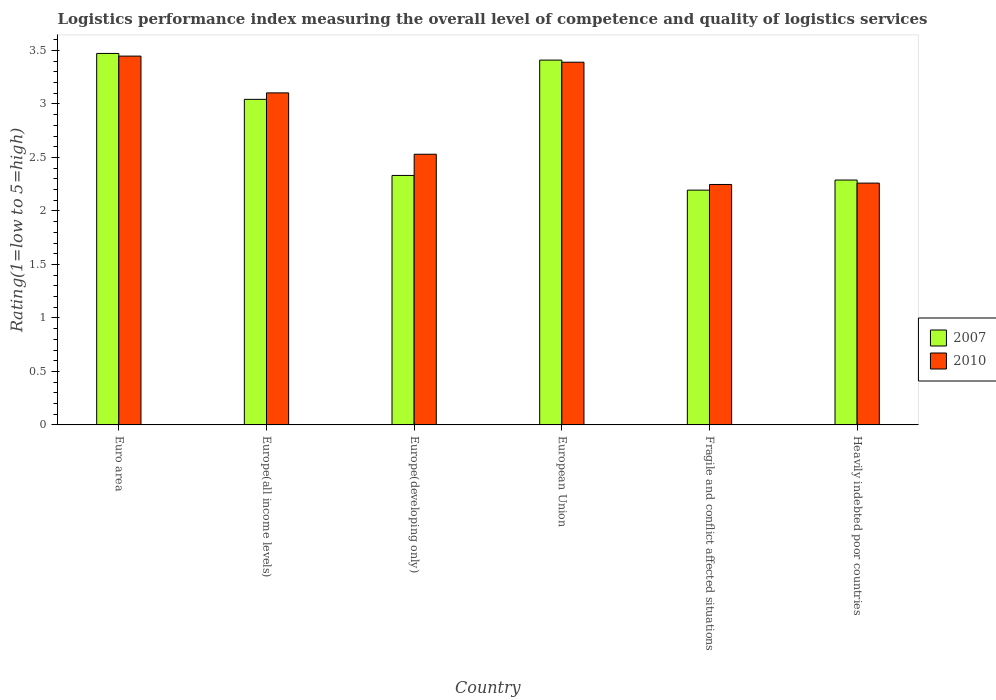How many different coloured bars are there?
Provide a short and direct response. 2. How many bars are there on the 4th tick from the left?
Provide a succinct answer. 2. What is the label of the 3rd group of bars from the left?
Give a very brief answer. Europe(developing only). What is the Logistic performance index in 2007 in Europe(developing only)?
Ensure brevity in your answer.  2.33. Across all countries, what is the maximum Logistic performance index in 2007?
Offer a terse response. 3.47. Across all countries, what is the minimum Logistic performance index in 2007?
Your answer should be compact. 2.19. In which country was the Logistic performance index in 2010 maximum?
Keep it short and to the point. Euro area. In which country was the Logistic performance index in 2007 minimum?
Offer a terse response. Fragile and conflict affected situations. What is the total Logistic performance index in 2007 in the graph?
Your answer should be very brief. 16.74. What is the difference between the Logistic performance index in 2010 in Europe(all income levels) and that in European Union?
Provide a succinct answer. -0.29. What is the difference between the Logistic performance index in 2007 in Heavily indebted poor countries and the Logistic performance index in 2010 in Europe(all income levels)?
Keep it short and to the point. -0.81. What is the average Logistic performance index in 2007 per country?
Provide a short and direct response. 2.79. What is the difference between the Logistic performance index of/in 2010 and Logistic performance index of/in 2007 in Euro area?
Offer a terse response. -0.02. What is the ratio of the Logistic performance index in 2010 in Europe(all income levels) to that in Fragile and conflict affected situations?
Offer a terse response. 1.38. Is the Logistic performance index in 2010 in Euro area less than that in Europe(all income levels)?
Keep it short and to the point. No. What is the difference between the highest and the second highest Logistic performance index in 2010?
Your answer should be compact. -0.06. What is the difference between the highest and the lowest Logistic performance index in 2010?
Offer a terse response. 1.2. In how many countries, is the Logistic performance index in 2007 greater than the average Logistic performance index in 2007 taken over all countries?
Ensure brevity in your answer.  3. What does the 1st bar from the right in European Union represents?
Offer a terse response. 2010. What is the difference between two consecutive major ticks on the Y-axis?
Your answer should be compact. 0.5. Are the values on the major ticks of Y-axis written in scientific E-notation?
Your response must be concise. No. Does the graph contain any zero values?
Provide a succinct answer. No. Where does the legend appear in the graph?
Offer a very short reply. Center right. How many legend labels are there?
Keep it short and to the point. 2. How are the legend labels stacked?
Provide a short and direct response. Vertical. What is the title of the graph?
Provide a succinct answer. Logistics performance index measuring the overall level of competence and quality of logistics services. What is the label or title of the Y-axis?
Your answer should be very brief. Rating(1=low to 5=high). What is the Rating(1=low to 5=high) of 2007 in Euro area?
Your answer should be very brief. 3.47. What is the Rating(1=low to 5=high) of 2010 in Euro area?
Your response must be concise. 3.45. What is the Rating(1=low to 5=high) of 2007 in Europe(all income levels)?
Your answer should be compact. 3.04. What is the Rating(1=low to 5=high) of 2010 in Europe(all income levels)?
Offer a terse response. 3.1. What is the Rating(1=low to 5=high) of 2007 in Europe(developing only)?
Offer a terse response. 2.33. What is the Rating(1=low to 5=high) in 2010 in Europe(developing only)?
Your answer should be very brief. 2.53. What is the Rating(1=low to 5=high) of 2007 in European Union?
Keep it short and to the point. 3.41. What is the Rating(1=low to 5=high) of 2010 in European Union?
Ensure brevity in your answer.  3.39. What is the Rating(1=low to 5=high) of 2007 in Fragile and conflict affected situations?
Ensure brevity in your answer.  2.19. What is the Rating(1=low to 5=high) in 2010 in Fragile and conflict affected situations?
Make the answer very short. 2.25. What is the Rating(1=low to 5=high) of 2007 in Heavily indebted poor countries?
Ensure brevity in your answer.  2.29. What is the Rating(1=low to 5=high) in 2010 in Heavily indebted poor countries?
Offer a very short reply. 2.26. Across all countries, what is the maximum Rating(1=low to 5=high) in 2007?
Your answer should be very brief. 3.47. Across all countries, what is the maximum Rating(1=low to 5=high) in 2010?
Make the answer very short. 3.45. Across all countries, what is the minimum Rating(1=low to 5=high) in 2007?
Your answer should be very brief. 2.19. Across all countries, what is the minimum Rating(1=low to 5=high) of 2010?
Your answer should be compact. 2.25. What is the total Rating(1=low to 5=high) in 2007 in the graph?
Provide a succinct answer. 16.74. What is the total Rating(1=low to 5=high) in 2010 in the graph?
Offer a very short reply. 16.98. What is the difference between the Rating(1=low to 5=high) in 2007 in Euro area and that in Europe(all income levels)?
Offer a terse response. 0.43. What is the difference between the Rating(1=low to 5=high) of 2010 in Euro area and that in Europe(all income levels)?
Offer a very short reply. 0.34. What is the difference between the Rating(1=low to 5=high) in 2007 in Euro area and that in Europe(developing only)?
Offer a terse response. 1.14. What is the difference between the Rating(1=low to 5=high) of 2010 in Euro area and that in Europe(developing only)?
Provide a succinct answer. 0.92. What is the difference between the Rating(1=low to 5=high) of 2007 in Euro area and that in European Union?
Provide a succinct answer. 0.06. What is the difference between the Rating(1=low to 5=high) in 2010 in Euro area and that in European Union?
Keep it short and to the point. 0.06. What is the difference between the Rating(1=low to 5=high) of 2007 in Euro area and that in Fragile and conflict affected situations?
Offer a very short reply. 1.28. What is the difference between the Rating(1=low to 5=high) of 2010 in Euro area and that in Fragile and conflict affected situations?
Provide a succinct answer. 1.2. What is the difference between the Rating(1=low to 5=high) in 2007 in Euro area and that in Heavily indebted poor countries?
Ensure brevity in your answer.  1.18. What is the difference between the Rating(1=low to 5=high) of 2010 in Euro area and that in Heavily indebted poor countries?
Give a very brief answer. 1.19. What is the difference between the Rating(1=low to 5=high) of 2007 in Europe(all income levels) and that in Europe(developing only)?
Your response must be concise. 0.71. What is the difference between the Rating(1=low to 5=high) of 2010 in Europe(all income levels) and that in Europe(developing only)?
Offer a terse response. 0.57. What is the difference between the Rating(1=low to 5=high) of 2007 in Europe(all income levels) and that in European Union?
Keep it short and to the point. -0.37. What is the difference between the Rating(1=low to 5=high) in 2010 in Europe(all income levels) and that in European Union?
Offer a very short reply. -0.29. What is the difference between the Rating(1=low to 5=high) in 2007 in Europe(all income levels) and that in Fragile and conflict affected situations?
Offer a terse response. 0.85. What is the difference between the Rating(1=low to 5=high) in 2010 in Europe(all income levels) and that in Fragile and conflict affected situations?
Your answer should be very brief. 0.86. What is the difference between the Rating(1=low to 5=high) in 2007 in Europe(all income levels) and that in Heavily indebted poor countries?
Keep it short and to the point. 0.75. What is the difference between the Rating(1=low to 5=high) of 2010 in Europe(all income levels) and that in Heavily indebted poor countries?
Provide a short and direct response. 0.84. What is the difference between the Rating(1=low to 5=high) of 2007 in Europe(developing only) and that in European Union?
Your answer should be very brief. -1.08. What is the difference between the Rating(1=low to 5=high) in 2010 in Europe(developing only) and that in European Union?
Give a very brief answer. -0.86. What is the difference between the Rating(1=low to 5=high) of 2007 in Europe(developing only) and that in Fragile and conflict affected situations?
Provide a succinct answer. 0.14. What is the difference between the Rating(1=low to 5=high) in 2010 in Europe(developing only) and that in Fragile and conflict affected situations?
Keep it short and to the point. 0.28. What is the difference between the Rating(1=low to 5=high) of 2007 in Europe(developing only) and that in Heavily indebted poor countries?
Make the answer very short. 0.04. What is the difference between the Rating(1=low to 5=high) in 2010 in Europe(developing only) and that in Heavily indebted poor countries?
Provide a short and direct response. 0.27. What is the difference between the Rating(1=low to 5=high) in 2007 in European Union and that in Fragile and conflict affected situations?
Offer a terse response. 1.22. What is the difference between the Rating(1=low to 5=high) in 2007 in European Union and that in Heavily indebted poor countries?
Offer a very short reply. 1.12. What is the difference between the Rating(1=low to 5=high) of 2010 in European Union and that in Heavily indebted poor countries?
Keep it short and to the point. 1.13. What is the difference between the Rating(1=low to 5=high) in 2007 in Fragile and conflict affected situations and that in Heavily indebted poor countries?
Keep it short and to the point. -0.09. What is the difference between the Rating(1=low to 5=high) in 2010 in Fragile and conflict affected situations and that in Heavily indebted poor countries?
Make the answer very short. -0.01. What is the difference between the Rating(1=low to 5=high) of 2007 in Euro area and the Rating(1=low to 5=high) of 2010 in Europe(all income levels)?
Provide a short and direct response. 0.37. What is the difference between the Rating(1=low to 5=high) in 2007 in Euro area and the Rating(1=low to 5=high) in 2010 in Europe(developing only)?
Give a very brief answer. 0.94. What is the difference between the Rating(1=low to 5=high) of 2007 in Euro area and the Rating(1=low to 5=high) of 2010 in European Union?
Offer a very short reply. 0.08. What is the difference between the Rating(1=low to 5=high) of 2007 in Euro area and the Rating(1=low to 5=high) of 2010 in Fragile and conflict affected situations?
Your response must be concise. 1.22. What is the difference between the Rating(1=low to 5=high) in 2007 in Euro area and the Rating(1=low to 5=high) in 2010 in Heavily indebted poor countries?
Your answer should be very brief. 1.21. What is the difference between the Rating(1=low to 5=high) of 2007 in Europe(all income levels) and the Rating(1=low to 5=high) of 2010 in Europe(developing only)?
Provide a succinct answer. 0.51. What is the difference between the Rating(1=low to 5=high) in 2007 in Europe(all income levels) and the Rating(1=low to 5=high) in 2010 in European Union?
Ensure brevity in your answer.  -0.35. What is the difference between the Rating(1=low to 5=high) in 2007 in Europe(all income levels) and the Rating(1=low to 5=high) in 2010 in Fragile and conflict affected situations?
Your answer should be very brief. 0.8. What is the difference between the Rating(1=low to 5=high) of 2007 in Europe(all income levels) and the Rating(1=low to 5=high) of 2010 in Heavily indebted poor countries?
Your answer should be compact. 0.78. What is the difference between the Rating(1=low to 5=high) in 2007 in Europe(developing only) and the Rating(1=low to 5=high) in 2010 in European Union?
Your response must be concise. -1.06. What is the difference between the Rating(1=low to 5=high) of 2007 in Europe(developing only) and the Rating(1=low to 5=high) of 2010 in Fragile and conflict affected situations?
Your answer should be very brief. 0.08. What is the difference between the Rating(1=low to 5=high) in 2007 in Europe(developing only) and the Rating(1=low to 5=high) in 2010 in Heavily indebted poor countries?
Provide a short and direct response. 0.07. What is the difference between the Rating(1=low to 5=high) of 2007 in European Union and the Rating(1=low to 5=high) of 2010 in Fragile and conflict affected situations?
Ensure brevity in your answer.  1.16. What is the difference between the Rating(1=low to 5=high) of 2007 in European Union and the Rating(1=low to 5=high) of 2010 in Heavily indebted poor countries?
Your answer should be very brief. 1.15. What is the difference between the Rating(1=low to 5=high) of 2007 in Fragile and conflict affected situations and the Rating(1=low to 5=high) of 2010 in Heavily indebted poor countries?
Provide a short and direct response. -0.07. What is the average Rating(1=low to 5=high) of 2007 per country?
Your answer should be compact. 2.79. What is the average Rating(1=low to 5=high) in 2010 per country?
Offer a terse response. 2.83. What is the difference between the Rating(1=low to 5=high) in 2007 and Rating(1=low to 5=high) in 2010 in Euro area?
Your answer should be compact. 0.02. What is the difference between the Rating(1=low to 5=high) of 2007 and Rating(1=low to 5=high) of 2010 in Europe(all income levels)?
Make the answer very short. -0.06. What is the difference between the Rating(1=low to 5=high) in 2007 and Rating(1=low to 5=high) in 2010 in Europe(developing only)?
Keep it short and to the point. -0.2. What is the difference between the Rating(1=low to 5=high) of 2007 and Rating(1=low to 5=high) of 2010 in European Union?
Provide a short and direct response. 0.02. What is the difference between the Rating(1=low to 5=high) in 2007 and Rating(1=low to 5=high) in 2010 in Fragile and conflict affected situations?
Make the answer very short. -0.05. What is the difference between the Rating(1=low to 5=high) in 2007 and Rating(1=low to 5=high) in 2010 in Heavily indebted poor countries?
Give a very brief answer. 0.03. What is the ratio of the Rating(1=low to 5=high) of 2007 in Euro area to that in Europe(all income levels)?
Your answer should be very brief. 1.14. What is the ratio of the Rating(1=low to 5=high) of 2010 in Euro area to that in Europe(all income levels)?
Offer a very short reply. 1.11. What is the ratio of the Rating(1=low to 5=high) in 2007 in Euro area to that in Europe(developing only)?
Make the answer very short. 1.49. What is the ratio of the Rating(1=low to 5=high) of 2010 in Euro area to that in Europe(developing only)?
Your answer should be compact. 1.36. What is the ratio of the Rating(1=low to 5=high) in 2007 in Euro area to that in European Union?
Ensure brevity in your answer.  1.02. What is the ratio of the Rating(1=low to 5=high) of 2010 in Euro area to that in European Union?
Provide a short and direct response. 1.02. What is the ratio of the Rating(1=low to 5=high) of 2007 in Euro area to that in Fragile and conflict affected situations?
Offer a very short reply. 1.58. What is the ratio of the Rating(1=low to 5=high) of 2010 in Euro area to that in Fragile and conflict affected situations?
Offer a very short reply. 1.53. What is the ratio of the Rating(1=low to 5=high) of 2007 in Euro area to that in Heavily indebted poor countries?
Your response must be concise. 1.52. What is the ratio of the Rating(1=low to 5=high) of 2010 in Euro area to that in Heavily indebted poor countries?
Offer a very short reply. 1.53. What is the ratio of the Rating(1=low to 5=high) in 2007 in Europe(all income levels) to that in Europe(developing only)?
Provide a succinct answer. 1.3. What is the ratio of the Rating(1=low to 5=high) of 2010 in Europe(all income levels) to that in Europe(developing only)?
Your response must be concise. 1.23. What is the ratio of the Rating(1=low to 5=high) in 2007 in Europe(all income levels) to that in European Union?
Your answer should be very brief. 0.89. What is the ratio of the Rating(1=low to 5=high) in 2010 in Europe(all income levels) to that in European Union?
Provide a short and direct response. 0.92. What is the ratio of the Rating(1=low to 5=high) of 2007 in Europe(all income levels) to that in Fragile and conflict affected situations?
Make the answer very short. 1.39. What is the ratio of the Rating(1=low to 5=high) of 2010 in Europe(all income levels) to that in Fragile and conflict affected situations?
Give a very brief answer. 1.38. What is the ratio of the Rating(1=low to 5=high) in 2007 in Europe(all income levels) to that in Heavily indebted poor countries?
Give a very brief answer. 1.33. What is the ratio of the Rating(1=low to 5=high) of 2010 in Europe(all income levels) to that in Heavily indebted poor countries?
Offer a terse response. 1.37. What is the ratio of the Rating(1=low to 5=high) of 2007 in Europe(developing only) to that in European Union?
Your response must be concise. 0.68. What is the ratio of the Rating(1=low to 5=high) of 2010 in Europe(developing only) to that in European Union?
Give a very brief answer. 0.75. What is the ratio of the Rating(1=low to 5=high) of 2007 in Europe(developing only) to that in Fragile and conflict affected situations?
Offer a terse response. 1.06. What is the ratio of the Rating(1=low to 5=high) of 2010 in Europe(developing only) to that in Fragile and conflict affected situations?
Make the answer very short. 1.13. What is the ratio of the Rating(1=low to 5=high) of 2007 in Europe(developing only) to that in Heavily indebted poor countries?
Ensure brevity in your answer.  1.02. What is the ratio of the Rating(1=low to 5=high) of 2010 in Europe(developing only) to that in Heavily indebted poor countries?
Give a very brief answer. 1.12. What is the ratio of the Rating(1=low to 5=high) of 2007 in European Union to that in Fragile and conflict affected situations?
Provide a succinct answer. 1.55. What is the ratio of the Rating(1=low to 5=high) of 2010 in European Union to that in Fragile and conflict affected situations?
Give a very brief answer. 1.51. What is the ratio of the Rating(1=low to 5=high) of 2007 in European Union to that in Heavily indebted poor countries?
Provide a short and direct response. 1.49. What is the ratio of the Rating(1=low to 5=high) in 2010 in European Union to that in Heavily indebted poor countries?
Your answer should be very brief. 1.5. What is the ratio of the Rating(1=low to 5=high) in 2007 in Fragile and conflict affected situations to that in Heavily indebted poor countries?
Your answer should be very brief. 0.96. What is the difference between the highest and the second highest Rating(1=low to 5=high) of 2007?
Keep it short and to the point. 0.06. What is the difference between the highest and the second highest Rating(1=low to 5=high) of 2010?
Ensure brevity in your answer.  0.06. What is the difference between the highest and the lowest Rating(1=low to 5=high) in 2007?
Offer a terse response. 1.28. What is the difference between the highest and the lowest Rating(1=low to 5=high) of 2010?
Give a very brief answer. 1.2. 